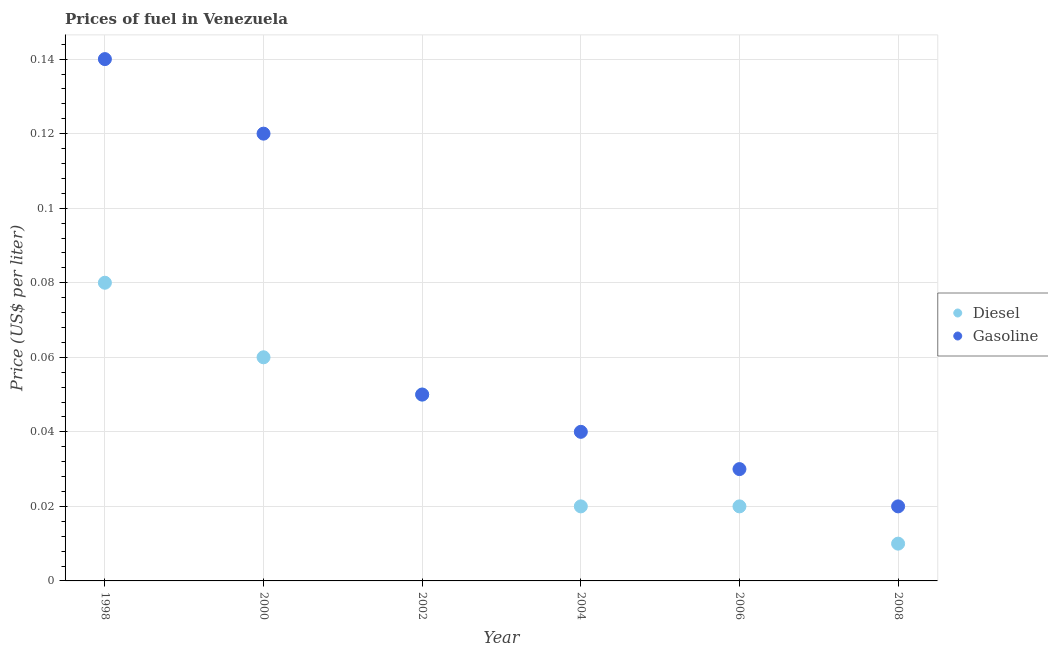What is the gasoline price in 2002?
Keep it short and to the point. 0.05. What is the total diesel price in the graph?
Give a very brief answer. 0.24. What is the difference between the diesel price in 1998 and that in 2008?
Make the answer very short. 0.07. What is the difference between the gasoline price in 2006 and the diesel price in 2004?
Keep it short and to the point. 0.01. What is the average gasoline price per year?
Your response must be concise. 0.07. In how many years, is the diesel price greater than 0.10400000000000001 US$ per litre?
Your answer should be compact. 0. Is the gasoline price in 2004 less than that in 2008?
Your answer should be compact. No. What is the difference between the highest and the second highest gasoline price?
Ensure brevity in your answer.  0.02. What is the difference between the highest and the lowest gasoline price?
Provide a succinct answer. 0.12. Is the sum of the gasoline price in 1998 and 2008 greater than the maximum diesel price across all years?
Keep it short and to the point. Yes. Does the gasoline price monotonically increase over the years?
Your response must be concise. No. Is the gasoline price strictly greater than the diesel price over the years?
Ensure brevity in your answer.  No. How many dotlines are there?
Your answer should be compact. 2. How many years are there in the graph?
Provide a succinct answer. 6. Are the values on the major ticks of Y-axis written in scientific E-notation?
Your response must be concise. No. Does the graph contain any zero values?
Provide a succinct answer. No. Does the graph contain grids?
Ensure brevity in your answer.  Yes. What is the title of the graph?
Keep it short and to the point. Prices of fuel in Venezuela. Does "Resident" appear as one of the legend labels in the graph?
Make the answer very short. No. What is the label or title of the X-axis?
Your response must be concise. Year. What is the label or title of the Y-axis?
Keep it short and to the point. Price (US$ per liter). What is the Price (US$ per liter) in Gasoline in 1998?
Provide a succinct answer. 0.14. What is the Price (US$ per liter) in Diesel in 2000?
Keep it short and to the point. 0.06. What is the Price (US$ per liter) in Gasoline in 2000?
Keep it short and to the point. 0.12. What is the Price (US$ per liter) of Diesel in 2002?
Provide a succinct answer. 0.05. What is the Price (US$ per liter) of Diesel in 2006?
Ensure brevity in your answer.  0.02. What is the Price (US$ per liter) of Gasoline in 2006?
Ensure brevity in your answer.  0.03. Across all years, what is the maximum Price (US$ per liter) in Diesel?
Your answer should be very brief. 0.08. Across all years, what is the maximum Price (US$ per liter) of Gasoline?
Offer a terse response. 0.14. What is the total Price (US$ per liter) in Diesel in the graph?
Ensure brevity in your answer.  0.24. What is the difference between the Price (US$ per liter) in Diesel in 1998 and that in 2000?
Your answer should be very brief. 0.02. What is the difference between the Price (US$ per liter) in Gasoline in 1998 and that in 2002?
Your response must be concise. 0.09. What is the difference between the Price (US$ per liter) in Gasoline in 1998 and that in 2006?
Your response must be concise. 0.11. What is the difference between the Price (US$ per liter) of Diesel in 1998 and that in 2008?
Provide a short and direct response. 0.07. What is the difference between the Price (US$ per liter) of Gasoline in 1998 and that in 2008?
Your response must be concise. 0.12. What is the difference between the Price (US$ per liter) in Diesel in 2000 and that in 2002?
Your response must be concise. 0.01. What is the difference between the Price (US$ per liter) in Gasoline in 2000 and that in 2002?
Provide a short and direct response. 0.07. What is the difference between the Price (US$ per liter) of Diesel in 2000 and that in 2004?
Offer a terse response. 0.04. What is the difference between the Price (US$ per liter) in Gasoline in 2000 and that in 2006?
Your response must be concise. 0.09. What is the difference between the Price (US$ per liter) in Gasoline in 2000 and that in 2008?
Your answer should be compact. 0.1. What is the difference between the Price (US$ per liter) in Gasoline in 2002 and that in 2004?
Give a very brief answer. 0.01. What is the difference between the Price (US$ per liter) of Gasoline in 2002 and that in 2006?
Keep it short and to the point. 0.02. What is the difference between the Price (US$ per liter) of Diesel in 2002 and that in 2008?
Offer a very short reply. 0.04. What is the difference between the Price (US$ per liter) of Gasoline in 2002 and that in 2008?
Provide a succinct answer. 0.03. What is the difference between the Price (US$ per liter) in Diesel in 2004 and that in 2006?
Keep it short and to the point. 0. What is the difference between the Price (US$ per liter) of Gasoline in 2004 and that in 2006?
Your response must be concise. 0.01. What is the difference between the Price (US$ per liter) in Diesel in 1998 and the Price (US$ per liter) in Gasoline in 2000?
Give a very brief answer. -0.04. What is the difference between the Price (US$ per liter) of Diesel in 1998 and the Price (US$ per liter) of Gasoline in 2004?
Your answer should be very brief. 0.04. What is the difference between the Price (US$ per liter) in Diesel in 1998 and the Price (US$ per liter) in Gasoline in 2008?
Keep it short and to the point. 0.06. What is the difference between the Price (US$ per liter) of Diesel in 2000 and the Price (US$ per liter) of Gasoline in 2008?
Give a very brief answer. 0.04. What is the difference between the Price (US$ per liter) of Diesel in 2002 and the Price (US$ per liter) of Gasoline in 2004?
Offer a terse response. 0.01. What is the difference between the Price (US$ per liter) in Diesel in 2002 and the Price (US$ per liter) in Gasoline in 2006?
Give a very brief answer. 0.02. What is the difference between the Price (US$ per liter) of Diesel in 2002 and the Price (US$ per liter) of Gasoline in 2008?
Keep it short and to the point. 0.03. What is the difference between the Price (US$ per liter) of Diesel in 2004 and the Price (US$ per liter) of Gasoline in 2006?
Your response must be concise. -0.01. What is the difference between the Price (US$ per liter) in Diesel in 2006 and the Price (US$ per liter) in Gasoline in 2008?
Your answer should be compact. 0. What is the average Price (US$ per liter) in Diesel per year?
Your response must be concise. 0.04. What is the average Price (US$ per liter) of Gasoline per year?
Ensure brevity in your answer.  0.07. In the year 1998, what is the difference between the Price (US$ per liter) in Diesel and Price (US$ per liter) in Gasoline?
Provide a succinct answer. -0.06. In the year 2000, what is the difference between the Price (US$ per liter) of Diesel and Price (US$ per liter) of Gasoline?
Your response must be concise. -0.06. In the year 2004, what is the difference between the Price (US$ per liter) in Diesel and Price (US$ per liter) in Gasoline?
Your answer should be compact. -0.02. In the year 2006, what is the difference between the Price (US$ per liter) in Diesel and Price (US$ per liter) in Gasoline?
Provide a succinct answer. -0.01. In the year 2008, what is the difference between the Price (US$ per liter) in Diesel and Price (US$ per liter) in Gasoline?
Your response must be concise. -0.01. What is the ratio of the Price (US$ per liter) in Gasoline in 1998 to that in 2002?
Your response must be concise. 2.8. What is the ratio of the Price (US$ per liter) of Diesel in 1998 to that in 2004?
Offer a terse response. 4. What is the ratio of the Price (US$ per liter) in Diesel in 1998 to that in 2006?
Your answer should be compact. 4. What is the ratio of the Price (US$ per liter) in Gasoline in 1998 to that in 2006?
Offer a very short reply. 4.67. What is the ratio of the Price (US$ per liter) of Gasoline in 1998 to that in 2008?
Provide a succinct answer. 7. What is the ratio of the Price (US$ per liter) in Diesel in 2000 to that in 2008?
Provide a succinct answer. 6. What is the ratio of the Price (US$ per liter) in Gasoline in 2000 to that in 2008?
Provide a short and direct response. 6. What is the ratio of the Price (US$ per liter) of Diesel in 2002 to that in 2004?
Ensure brevity in your answer.  2.5. What is the ratio of the Price (US$ per liter) in Gasoline in 2002 to that in 2004?
Your response must be concise. 1.25. What is the ratio of the Price (US$ per liter) in Diesel in 2002 to that in 2006?
Keep it short and to the point. 2.5. What is the ratio of the Price (US$ per liter) of Gasoline in 2002 to that in 2006?
Your answer should be very brief. 1.67. What is the ratio of the Price (US$ per liter) in Diesel in 2002 to that in 2008?
Keep it short and to the point. 5. What is the ratio of the Price (US$ per liter) in Gasoline in 2002 to that in 2008?
Make the answer very short. 2.5. What is the ratio of the Price (US$ per liter) of Diesel in 2004 to that in 2006?
Provide a short and direct response. 1. What is the ratio of the Price (US$ per liter) of Gasoline in 2006 to that in 2008?
Offer a very short reply. 1.5. What is the difference between the highest and the second highest Price (US$ per liter) in Diesel?
Provide a succinct answer. 0.02. What is the difference between the highest and the lowest Price (US$ per liter) in Diesel?
Provide a short and direct response. 0.07. What is the difference between the highest and the lowest Price (US$ per liter) in Gasoline?
Ensure brevity in your answer.  0.12. 